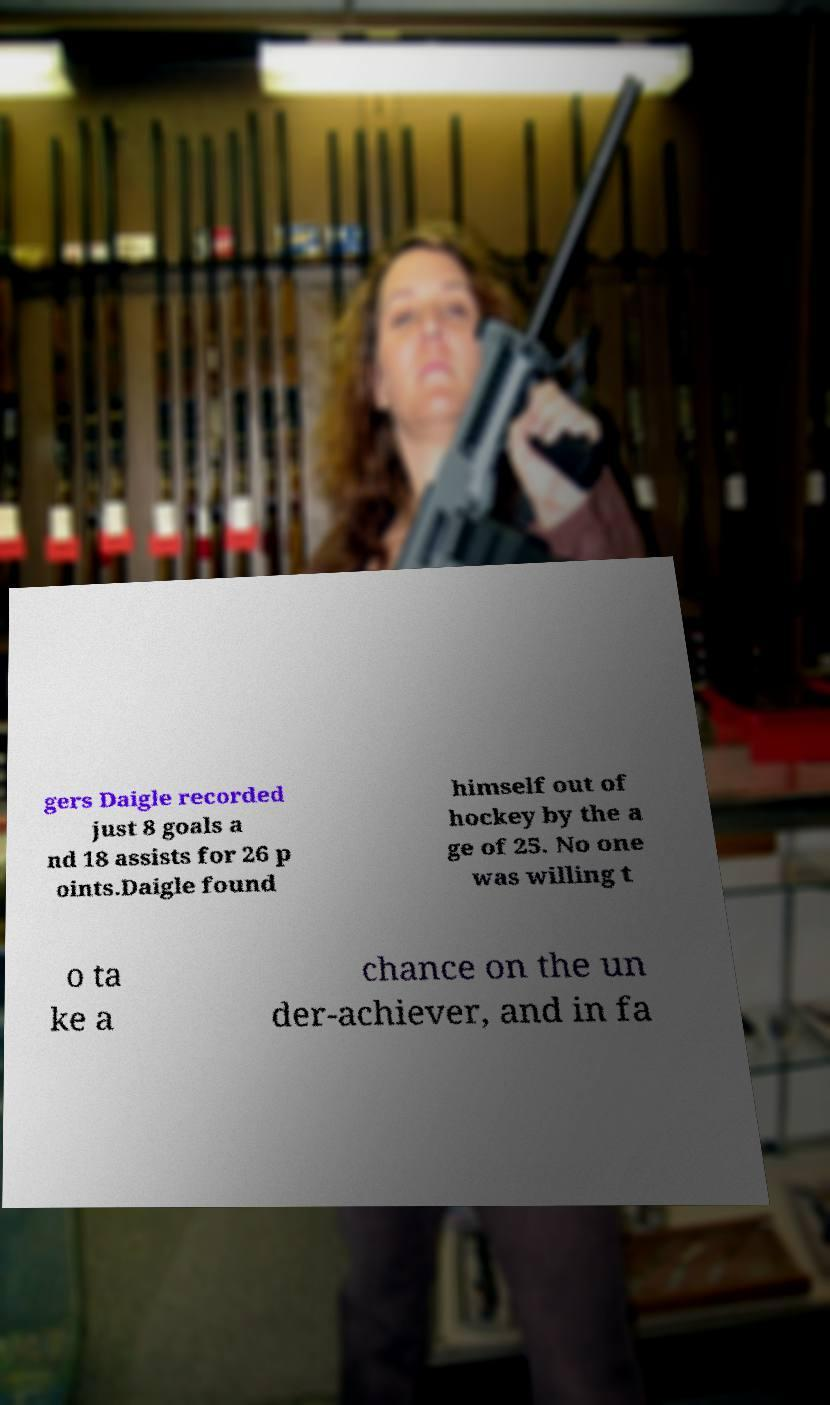Please read and relay the text visible in this image. What does it say? gers Daigle recorded just 8 goals a nd 18 assists for 26 p oints.Daigle found himself out of hockey by the a ge of 25. No one was willing t o ta ke a chance on the un der-achiever, and in fa 